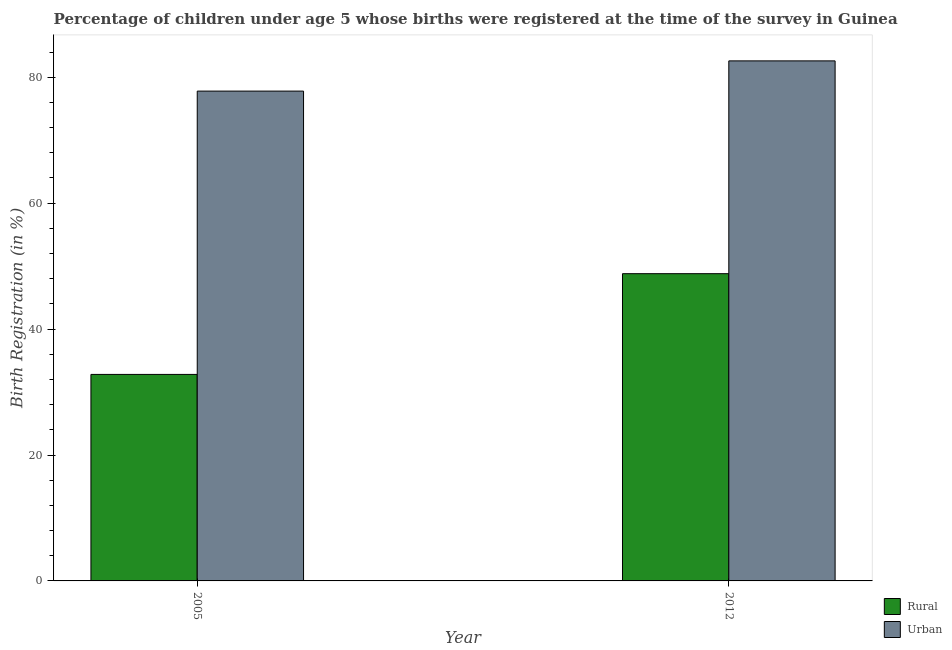How many groups of bars are there?
Ensure brevity in your answer.  2. Are the number of bars per tick equal to the number of legend labels?
Provide a short and direct response. Yes. Are the number of bars on each tick of the X-axis equal?
Provide a short and direct response. Yes. How many bars are there on the 1st tick from the left?
Your response must be concise. 2. How many bars are there on the 1st tick from the right?
Ensure brevity in your answer.  2. What is the urban birth registration in 2012?
Provide a short and direct response. 82.6. Across all years, what is the maximum urban birth registration?
Your answer should be compact. 82.6. Across all years, what is the minimum rural birth registration?
Your answer should be compact. 32.8. What is the total urban birth registration in the graph?
Your answer should be very brief. 160.4. What is the difference between the urban birth registration in 2005 and that in 2012?
Provide a short and direct response. -4.8. What is the average rural birth registration per year?
Provide a succinct answer. 40.8. In the year 2012, what is the difference between the rural birth registration and urban birth registration?
Your answer should be compact. 0. In how many years, is the rural birth registration greater than 28 %?
Your answer should be compact. 2. What is the ratio of the rural birth registration in 2005 to that in 2012?
Give a very brief answer. 0.67. What does the 2nd bar from the left in 2005 represents?
Your answer should be very brief. Urban. What does the 1st bar from the right in 2005 represents?
Make the answer very short. Urban. How many years are there in the graph?
Give a very brief answer. 2. Are the values on the major ticks of Y-axis written in scientific E-notation?
Provide a succinct answer. No. Where does the legend appear in the graph?
Give a very brief answer. Bottom right. What is the title of the graph?
Give a very brief answer. Percentage of children under age 5 whose births were registered at the time of the survey in Guinea. Does "Frequency of shipment arrival" appear as one of the legend labels in the graph?
Make the answer very short. No. What is the label or title of the X-axis?
Offer a very short reply. Year. What is the label or title of the Y-axis?
Ensure brevity in your answer.  Birth Registration (in %). What is the Birth Registration (in %) in Rural in 2005?
Make the answer very short. 32.8. What is the Birth Registration (in %) of Urban in 2005?
Keep it short and to the point. 77.8. What is the Birth Registration (in %) of Rural in 2012?
Keep it short and to the point. 48.8. What is the Birth Registration (in %) of Urban in 2012?
Your answer should be compact. 82.6. Across all years, what is the maximum Birth Registration (in %) of Rural?
Your answer should be very brief. 48.8. Across all years, what is the maximum Birth Registration (in %) of Urban?
Offer a terse response. 82.6. Across all years, what is the minimum Birth Registration (in %) of Rural?
Your answer should be compact. 32.8. Across all years, what is the minimum Birth Registration (in %) of Urban?
Ensure brevity in your answer.  77.8. What is the total Birth Registration (in %) of Rural in the graph?
Keep it short and to the point. 81.6. What is the total Birth Registration (in %) in Urban in the graph?
Give a very brief answer. 160.4. What is the difference between the Birth Registration (in %) of Rural in 2005 and that in 2012?
Your response must be concise. -16. What is the difference between the Birth Registration (in %) of Urban in 2005 and that in 2012?
Offer a terse response. -4.8. What is the difference between the Birth Registration (in %) of Rural in 2005 and the Birth Registration (in %) of Urban in 2012?
Give a very brief answer. -49.8. What is the average Birth Registration (in %) of Rural per year?
Give a very brief answer. 40.8. What is the average Birth Registration (in %) in Urban per year?
Your response must be concise. 80.2. In the year 2005, what is the difference between the Birth Registration (in %) in Rural and Birth Registration (in %) in Urban?
Provide a short and direct response. -45. In the year 2012, what is the difference between the Birth Registration (in %) of Rural and Birth Registration (in %) of Urban?
Ensure brevity in your answer.  -33.8. What is the ratio of the Birth Registration (in %) of Rural in 2005 to that in 2012?
Offer a very short reply. 0.67. What is the ratio of the Birth Registration (in %) in Urban in 2005 to that in 2012?
Make the answer very short. 0.94. What is the difference between the highest and the lowest Birth Registration (in %) in Urban?
Your response must be concise. 4.8. 